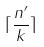<formula> <loc_0><loc_0><loc_500><loc_500>\lceil \frac { n ^ { \prime } } { k } \rceil</formula> 